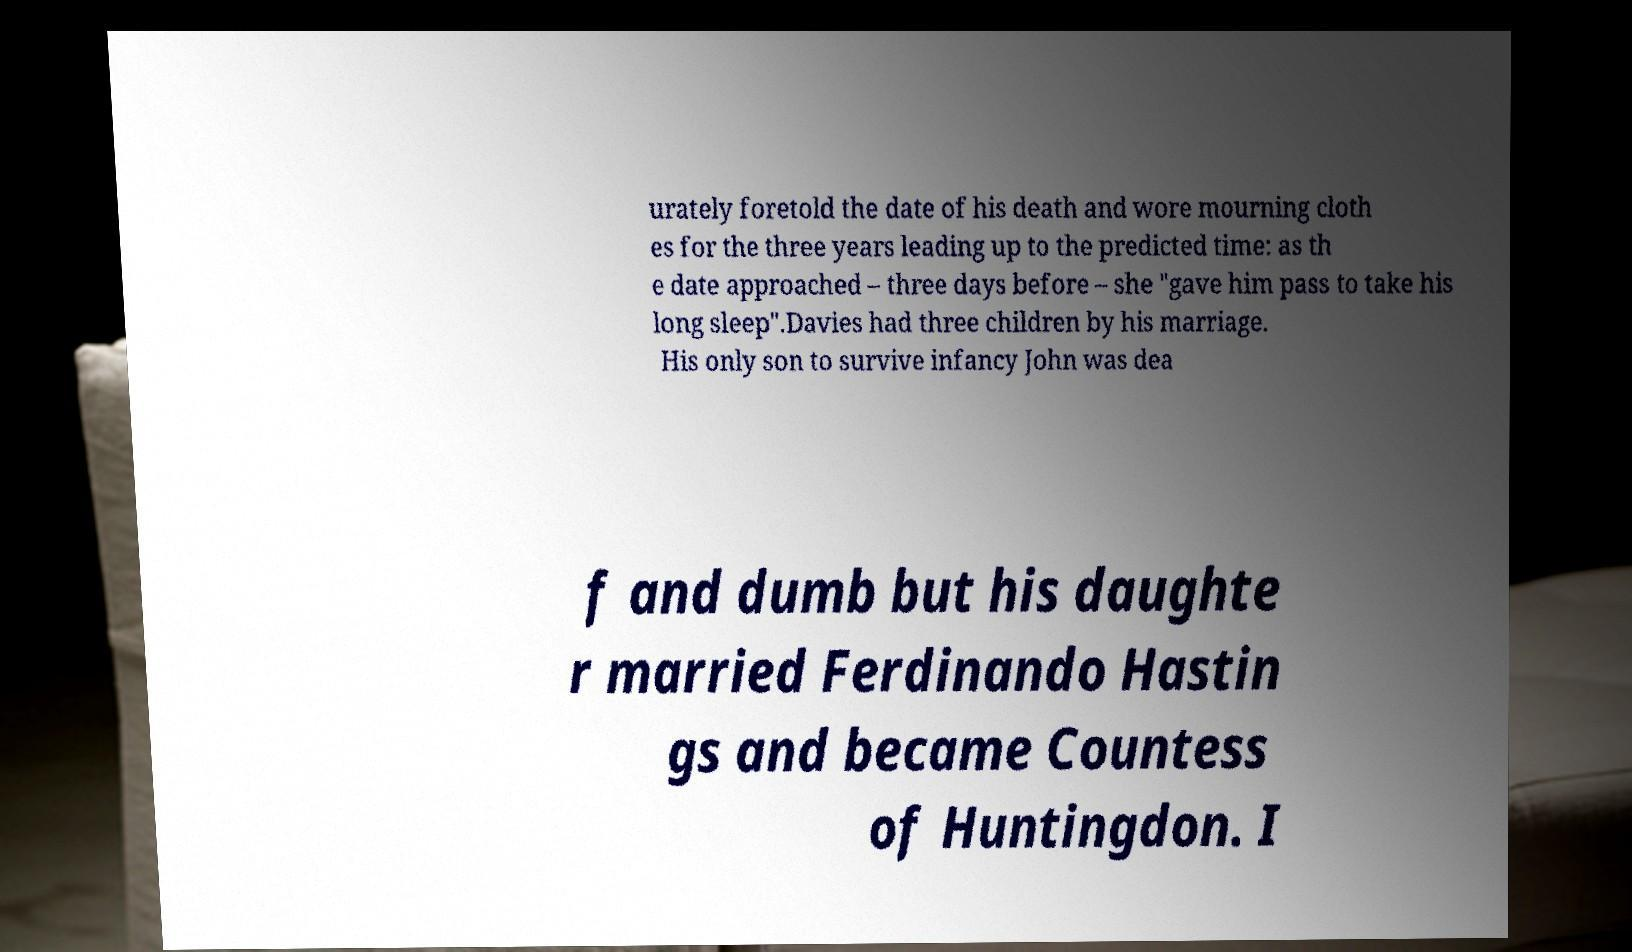Can you accurately transcribe the text from the provided image for me? urately foretold the date of his death and wore mourning cloth es for the three years leading up to the predicted time: as th e date approached – three days before – she "gave him pass to take his long sleep".Davies had three children by his marriage. His only son to survive infancy John was dea f and dumb but his daughte r married Ferdinando Hastin gs and became Countess of Huntingdon. I 